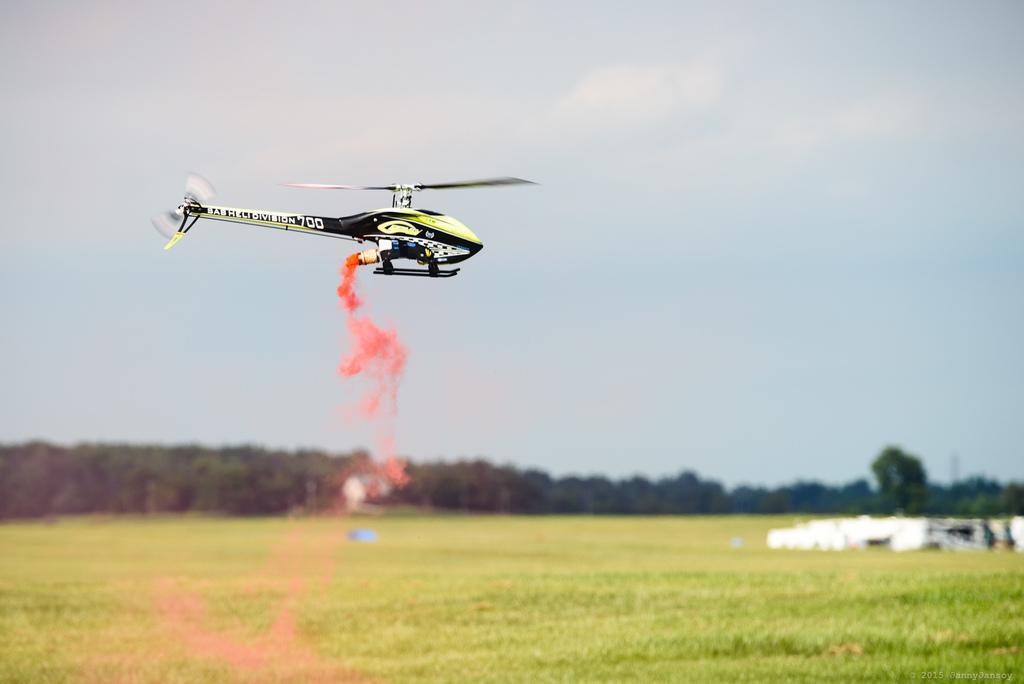Please provide a concise description of this image. This image is taken outdoors. At the top of the image there is the sky with clouds. In the background there are many trees. At the bottom of the image there is a ground with grass on it. In the middle of the image a toy chopper is flying in the air. 